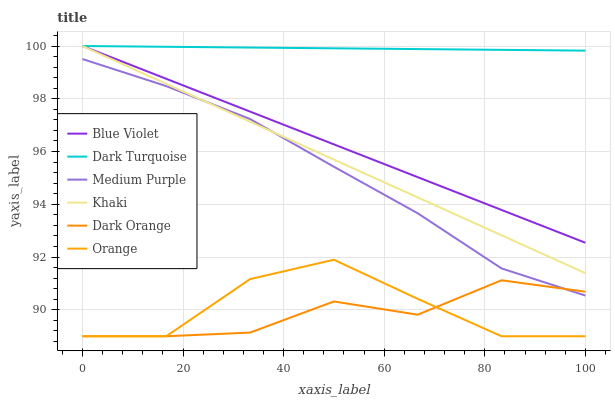Does Khaki have the minimum area under the curve?
Answer yes or no. No. Does Khaki have the maximum area under the curve?
Answer yes or no. No. Is Khaki the smoothest?
Answer yes or no. No. Is Khaki the roughest?
Answer yes or no. No. Does Khaki have the lowest value?
Answer yes or no. No. Does Medium Purple have the highest value?
Answer yes or no. No. Is Orange less than Khaki?
Answer yes or no. Yes. Is Blue Violet greater than Medium Purple?
Answer yes or no. Yes. Does Orange intersect Khaki?
Answer yes or no. No. 